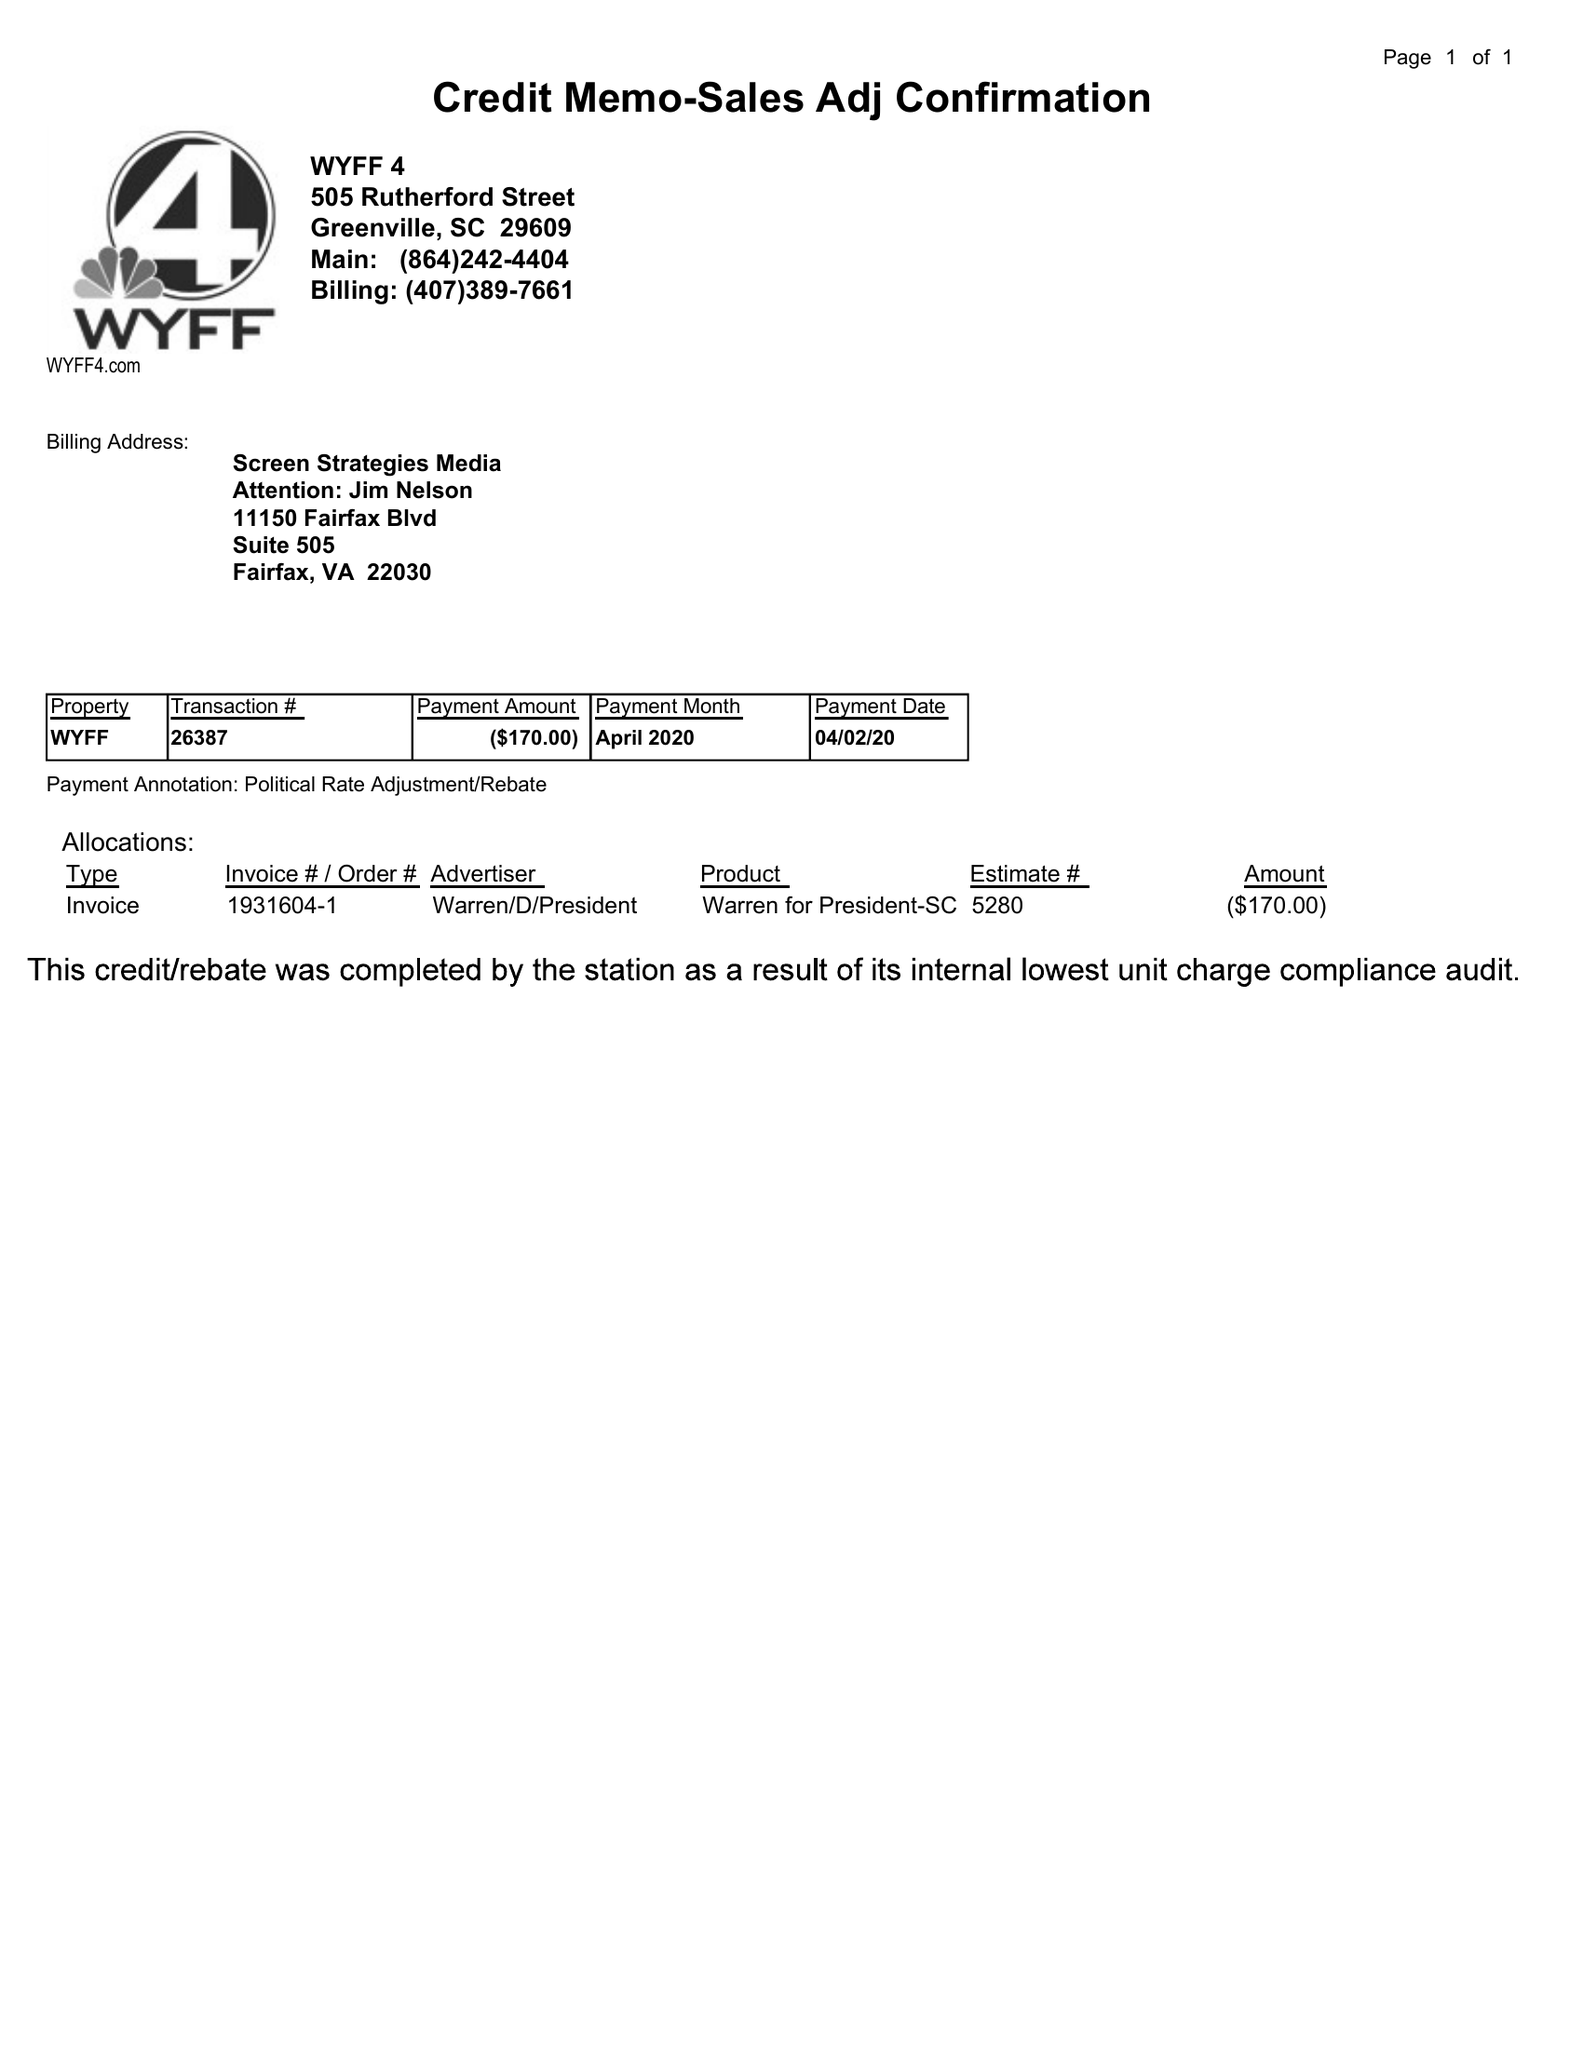What is the value for the advertiser?
Answer the question using a single word or phrase. WARREN/D/PRESIDENT 